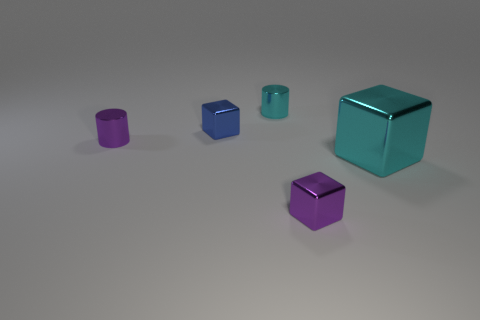Add 4 tiny cyan cylinders. How many objects exist? 9 Subtract all cylinders. How many objects are left? 3 Add 5 cyan metal cylinders. How many cyan metal cylinders exist? 6 Subtract 0 red blocks. How many objects are left? 5 Subtract all metal objects. Subtract all gray blocks. How many objects are left? 0 Add 3 small cyan objects. How many small cyan objects are left? 4 